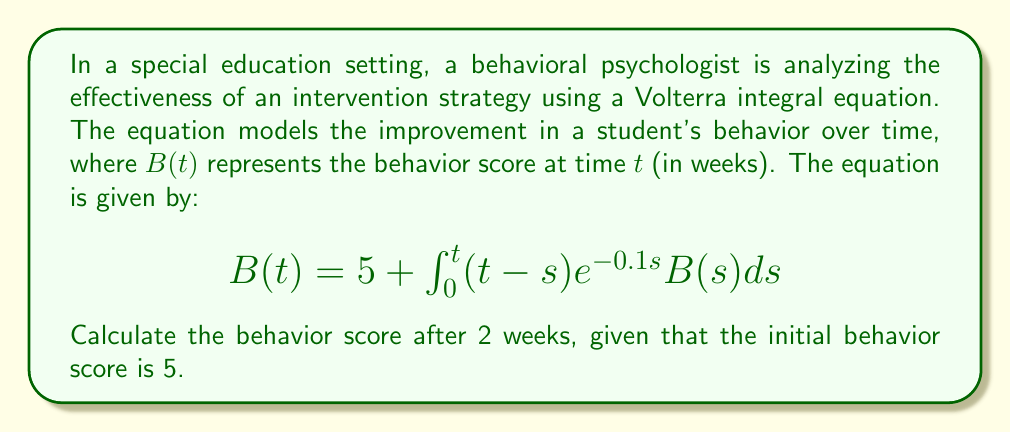Solve this math problem. To solve this Volterra integral equation, we'll use the method of successive approximations:

1) Start with the initial approximation $B_0(t) = 5$

2) Substitute this into the integral equation to get the next approximation:

   $$B_1(t) = 5 + \int_0^t (t-s)e^{-0.1s}(5)ds$$

3) Evaluate the integral:
   
   $$B_1(t) = 5 + 5\int_0^t (t-s)e^{-0.1s}ds$$
   $$= 5 + 5[-10(t-s)e^{-0.1s} - 100e^{-0.1s}]_0^t$$
   $$= 5 + 5[-10te^{-0.1t} + 100e^{-0.1t} + 100]$$
   $$= 5 + 500 - 50te^{-0.1t} + 500e^{-0.1t}$$

4) Now, we need to evaluate this at $t=2$:

   $$B_1(2) = 5 + 500 - 50(2)e^{-0.2} + 500e^{-0.2}$$
   $$= 505 - 100e^{-0.2} + 500e^{-0.2}$$
   $$= 505 + 400e^{-0.2}$$
   $$\approx 505 + 400(0.8187)$$
   $$\approx 832.48$$

5) For a more accurate result, we could continue this process to find $B_2(t)$, $B_3(t)$, etc. However, the first approximation gives us a reasonable estimate.
Answer: $832.48$ 